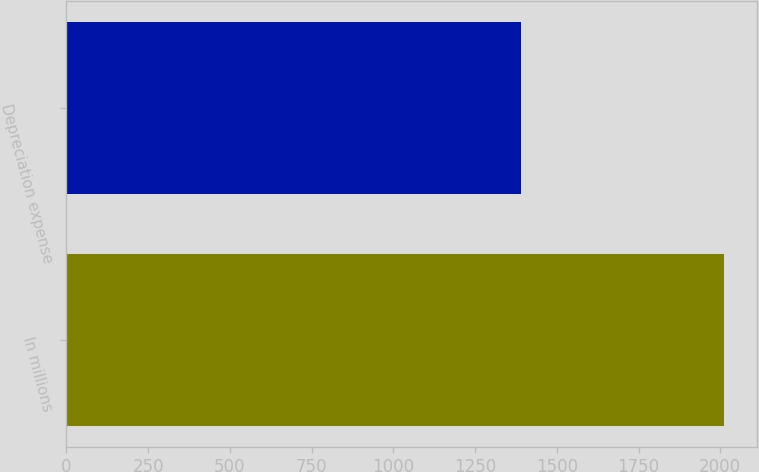Convert chart. <chart><loc_0><loc_0><loc_500><loc_500><bar_chart><fcel>In millions<fcel>Depreciation expense<nl><fcel>2012<fcel>1390<nl></chart> 